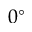Convert formula to latex. <formula><loc_0><loc_0><loc_500><loc_500>0 ^ { \circ }</formula> 